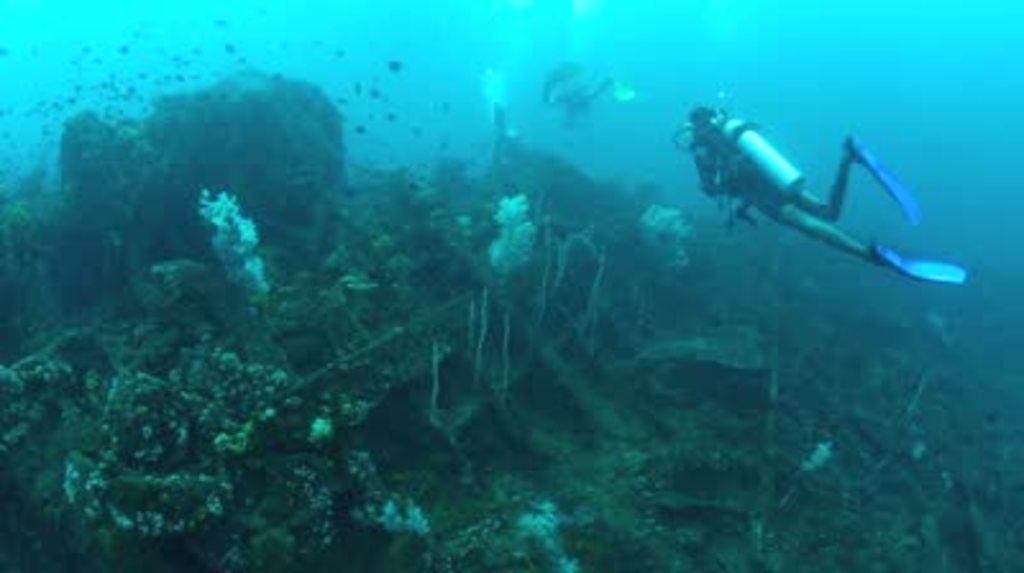How would you summarize this image in a sentence or two? In this picture we can see a person swimming in the water and he wore a oxygen cylinder. Here we can see corals. 